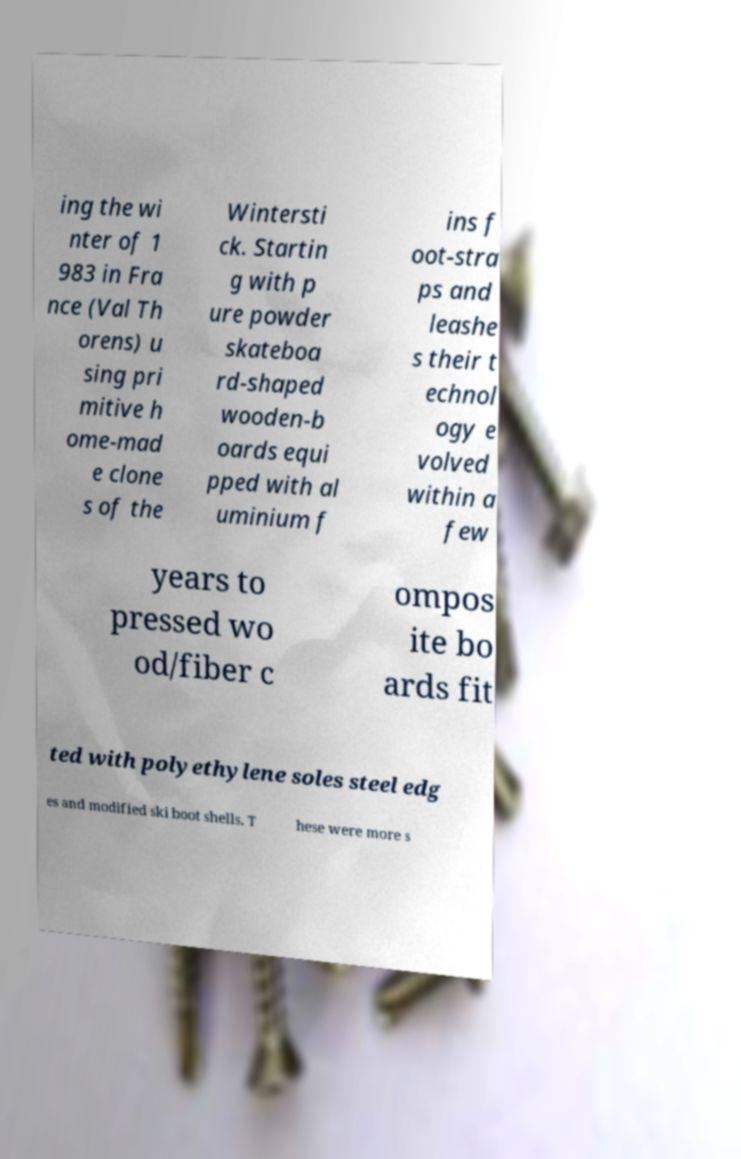Could you assist in decoding the text presented in this image and type it out clearly? ing the wi nter of 1 983 in Fra nce (Val Th orens) u sing pri mitive h ome-mad e clone s of the Wintersti ck. Startin g with p ure powder skateboa rd-shaped wooden-b oards equi pped with al uminium f ins f oot-stra ps and leashe s their t echnol ogy e volved within a few years to pressed wo od/fiber c ompos ite bo ards fit ted with polyethylene soles steel edg es and modified ski boot shells. T hese were more s 